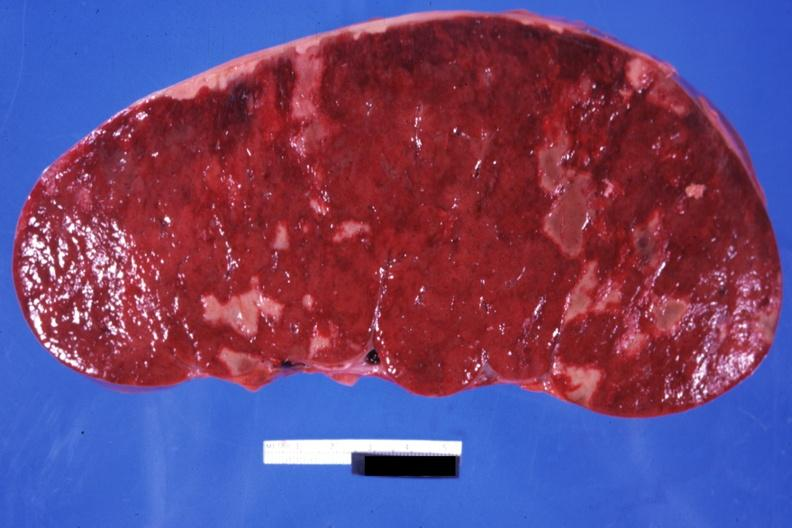does premature coronary disease show very enlarged spleen with multiple infarcts infiltrative process is easily seen?
Answer the question using a single word or phrase. No 